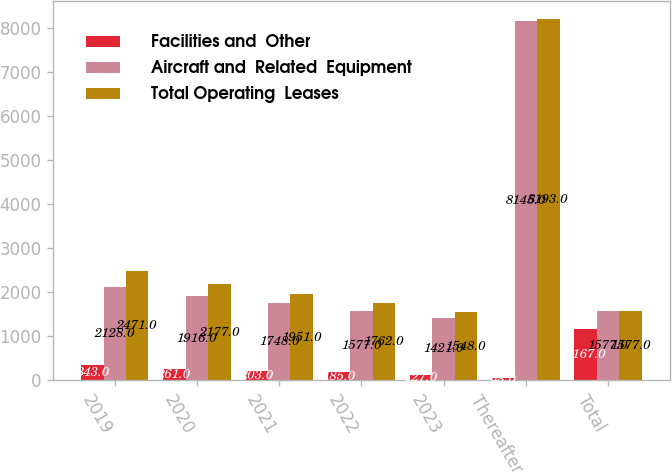Convert chart to OTSL. <chart><loc_0><loc_0><loc_500><loc_500><stacked_bar_chart><ecel><fcel>2019<fcel>2020<fcel>2021<fcel>2022<fcel>2023<fcel>Thereafter<fcel>Total<nl><fcel>Facilities and  Other<fcel>343<fcel>261<fcel>203<fcel>185<fcel>127<fcel>48<fcel>1167<nl><fcel>Aircraft and  Related  Equipment<fcel>2128<fcel>1916<fcel>1748<fcel>1577<fcel>1421<fcel>8145<fcel>1577<nl><fcel>Total Operating  Leases<fcel>2471<fcel>2177<fcel>1951<fcel>1762<fcel>1548<fcel>8193<fcel>1577<nl></chart> 